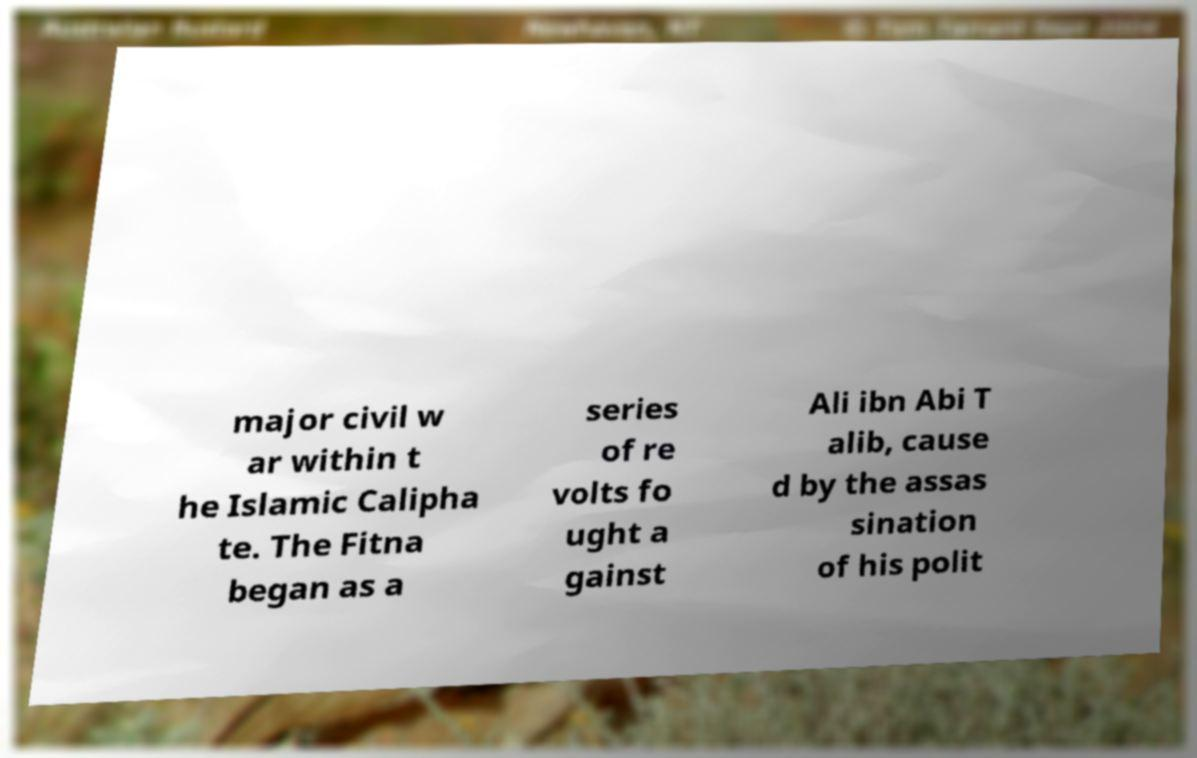Could you extract and type out the text from this image? major civil w ar within t he Islamic Calipha te. The Fitna began as a series of re volts fo ught a gainst Ali ibn Abi T alib, cause d by the assas sination of his polit 